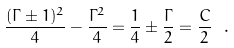Convert formula to latex. <formula><loc_0><loc_0><loc_500><loc_500>\frac { ( \Gamma \pm 1 ) ^ { 2 } } { 4 } - \frac { \Gamma ^ { 2 } } { 4 } = \frac { 1 } { 4 } \pm \frac { \Gamma } { 2 } = \frac { C } { 2 } \ . \label l { e q \colon s i l l y s u m s }</formula> 